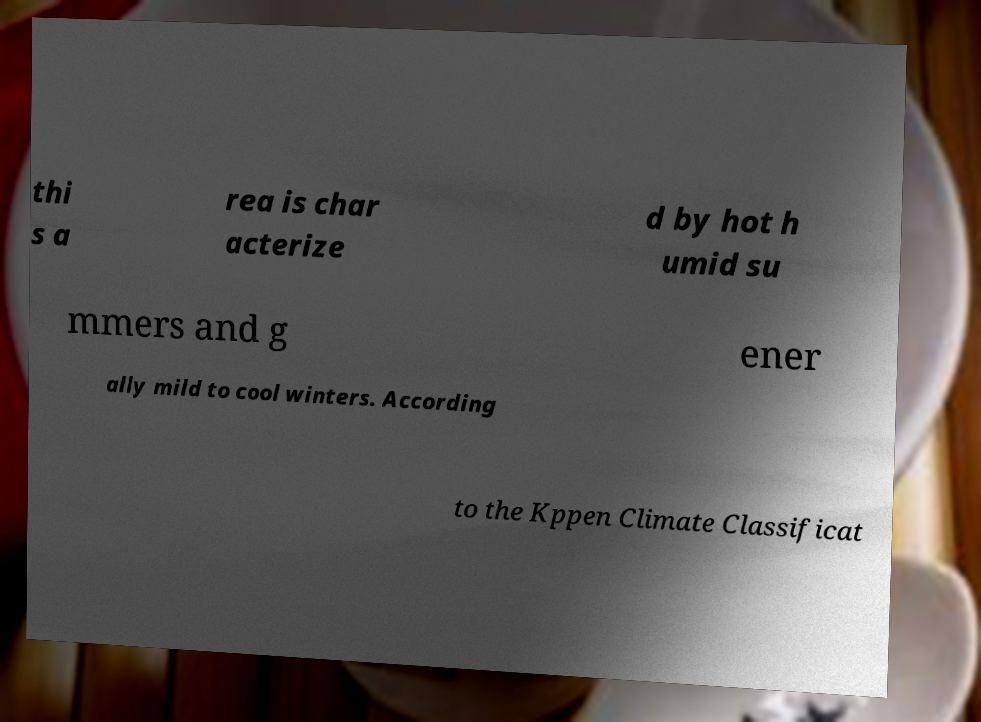I need the written content from this picture converted into text. Can you do that? thi s a rea is char acterize d by hot h umid su mmers and g ener ally mild to cool winters. According to the Kppen Climate Classificat 